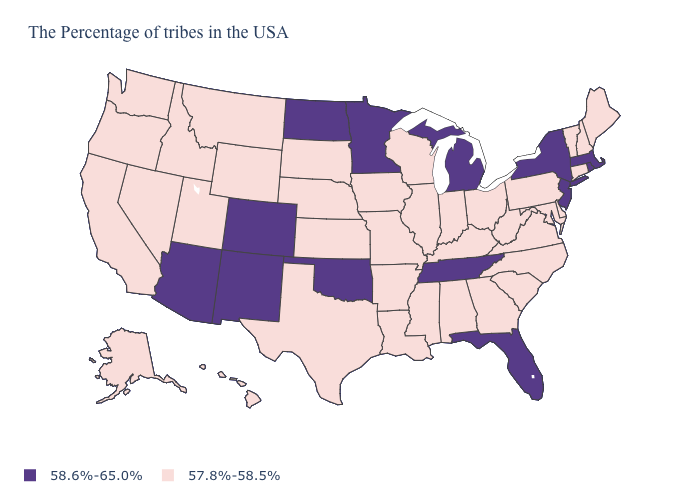Does Minnesota have the highest value in the USA?
Be succinct. Yes. What is the value of Oregon?
Short answer required. 57.8%-58.5%. What is the lowest value in the USA?
Keep it brief. 57.8%-58.5%. Does the map have missing data?
Concise answer only. No. Among the states that border New Jersey , which have the highest value?
Answer briefly. New York. What is the highest value in the USA?
Concise answer only. 58.6%-65.0%. What is the lowest value in the MidWest?
Concise answer only. 57.8%-58.5%. What is the value of Tennessee?
Answer briefly. 58.6%-65.0%. Does Pennsylvania have the lowest value in the Northeast?
Concise answer only. Yes. Name the states that have a value in the range 57.8%-58.5%?
Answer briefly. Maine, New Hampshire, Vermont, Connecticut, Delaware, Maryland, Pennsylvania, Virginia, North Carolina, South Carolina, West Virginia, Ohio, Georgia, Kentucky, Indiana, Alabama, Wisconsin, Illinois, Mississippi, Louisiana, Missouri, Arkansas, Iowa, Kansas, Nebraska, Texas, South Dakota, Wyoming, Utah, Montana, Idaho, Nevada, California, Washington, Oregon, Alaska, Hawaii. Does New Jersey have the lowest value in the Northeast?
Quick response, please. No. Does Tennessee have the highest value in the South?
Quick response, please. Yes. Among the states that border Rhode Island , does Connecticut have the highest value?
Answer briefly. No. What is the value of South Dakota?
Be succinct. 57.8%-58.5%. 